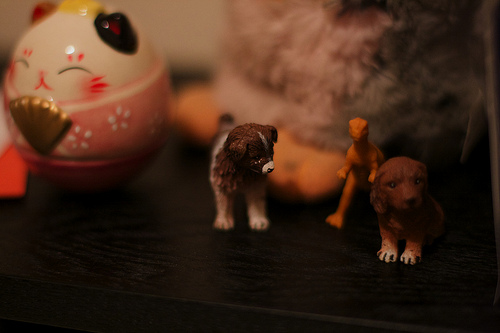<image>
Is the dinosaur in front of the puppy? No. The dinosaur is not in front of the puppy. The spatial positioning shows a different relationship between these objects. 